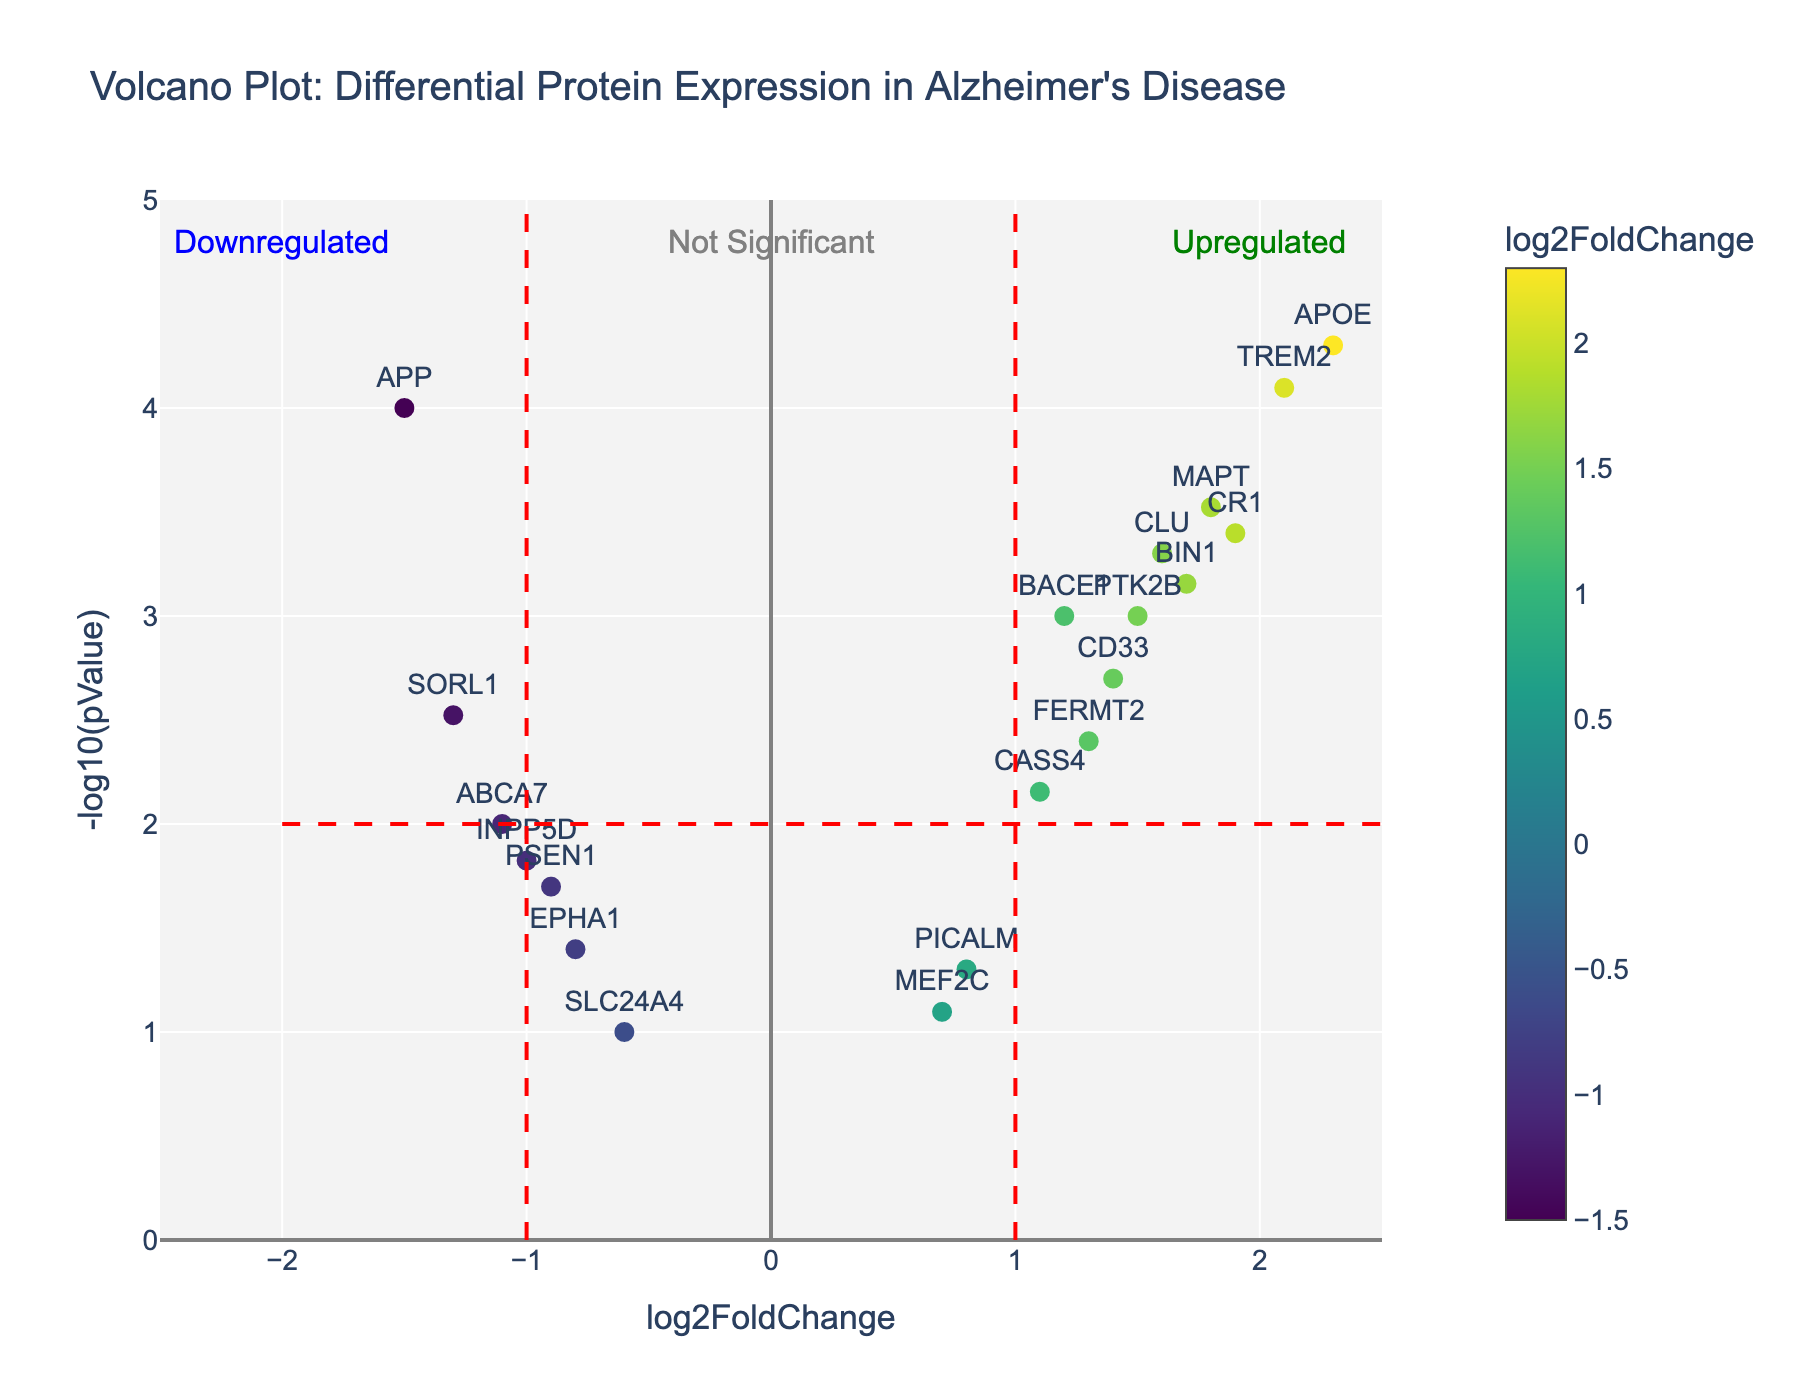What is the title of the figure? The title is located at the top of the figure. It reads "Volcano Plot: Differential Protein Expression in Alzheimer's Disease".
Answer: Volcano Plot: Differential Protein Expression in Alzheimer's Disease What are the x-axis and y-axis labels? The x-axis is labeled "log2FoldChange" and the y-axis is labeled "-log10(pValue)". These labels indicate the type of data each axis represents.
Answer: x-axis: log2FoldChange, y-axis: -log10(pValue) How many proteins are upregulated? Upregulated proteins have a positive log2FoldChange value (x-axis > 0). By counting the data points on the right side of the vertical line at x = 0, we find there are 10 upregulated proteins.
Answer: 10 Which protein has the highest -log10(pValue)? To find this, look for the point with the highest y-value on the plot. The highest -log10(pValue) is associated with the protein APOE.
Answer: APOE What color represents the most downregulated proteins? Downregulated proteins have negative log2FoldChange values and the color of these points can be observed as predominantly towards the end of the colormap. According to the 'Viridis' color scale, it would be a dark blue or purple color.
Answer: Dark blue or purple How many proteins are not significant (below the significance threshold)? The horizontal red dashed line at y = 2 (-log10(pValue) = 2, or pValue = 0.01) indicates the significance threshold. Proteins below this y-value are not significant. Counting the points below this line, we see there are 6 proteins.
Answer: 6 Compare the log2FoldChanges of APOE and APP. Which one is greater, and by how much? The log2FoldChange for APOE is 2.3 and for APP is -1.5. The difference is 2.3 - (-1.5) = 2.3 + 1.5 = 3.8.
Answer: APOE by 3.8 Which proteins are significantly upregulated? The significance threshold is -log10(pValue) = 2. Significantly upregulated proteins have log2FoldChange > 1 and -log10(pValue) > 2. By examining these criteria, the proteins APOE, TREM2, and CR1 meet both conditions.
Answer: APOE, TREM2, CR1 Is the protein BIN1 upregulated or downregulated, and is it significant? By locating BIN1 on the plot, we see it has a log2FoldChange of 1.7 (positive) and a -log10(pValue) of greater than 2. This means BIN1 is upregulated and significant.
Answer: Upregulated and significant 